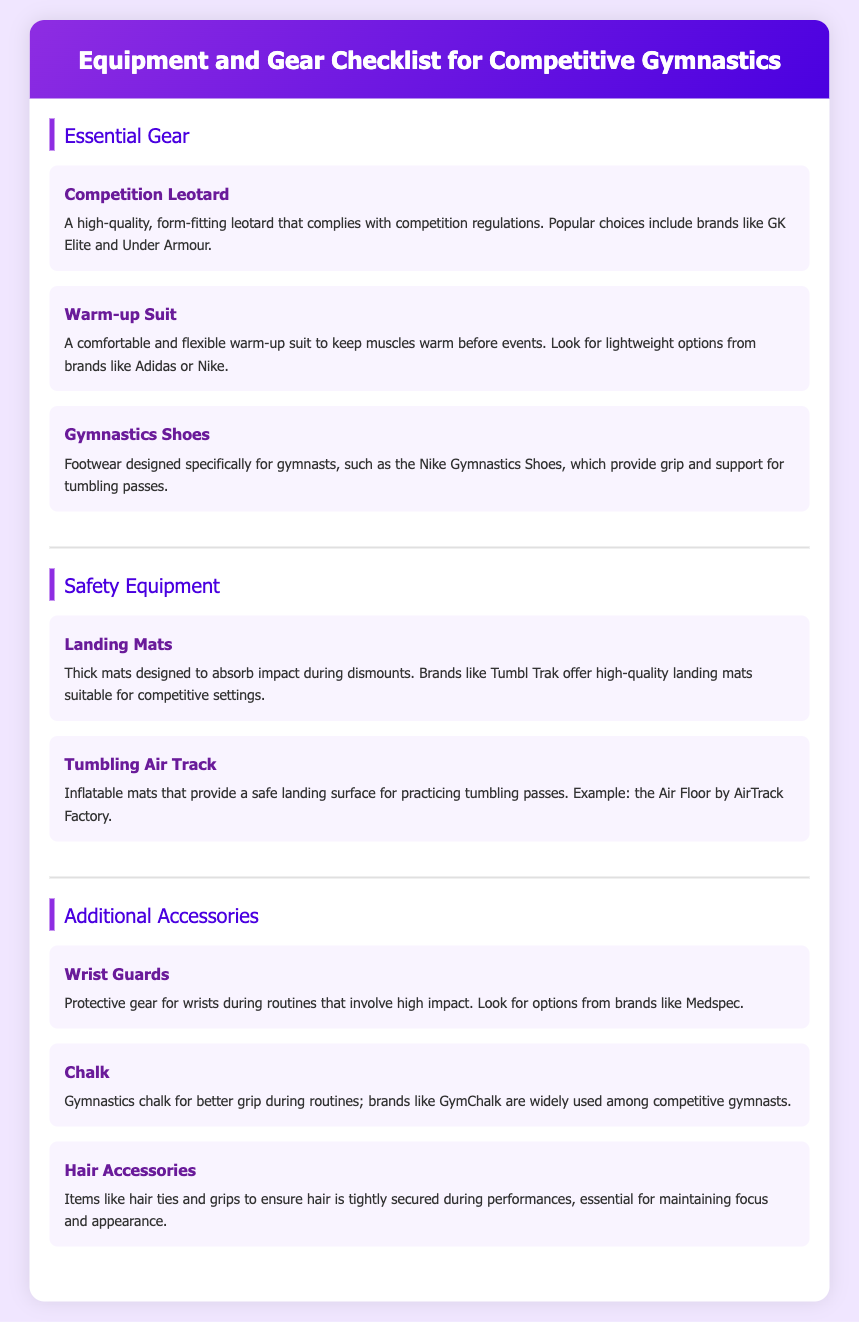What is the title of the document? The title of the document is provided in the header of the page, which states "Equipment and Gear Checklist for Competitive Gymnastics."
Answer: Equipment and Gear Checklist for Competitive Gymnastics Which brand is mentioned for competition leotards? The document specifies that popular choices for competition leotards include brands like GK Elite and Under Armour.
Answer: GK Elite What type of shoes are listed for gymnasts? The document names "Gymnastics Shoes" as the type of footwear designed specifically for gymnasts.
Answer: Gymnastics Shoes What do landing mats provide? According to the document, landing mats are designed to absorb impact during dismounts.
Answer: Absorb impact What is one example of additional accessories mentioned in the document? The listed additional accessories include wrist guards, chalk, and hair accessories; one example is "Wrist Guards."
Answer: Wrist Guards What material is suggested for warm-up suits? The document recommends looking for lightweight options in warm-up suits from brands like Adidas or Nike.
Answer: Lightweight options How many sections are there in the document? The document contains three main sections: Essential Gear, Safety Equipment, and Additional Accessories.
Answer: Three Which inflatable equipment is mentioned for practicing tumbling passes? The document specifies "Tumbling Air Track" as the inflatable equipment used for practicing tumbling.
Answer: Tumbling Air Track What is the purpose of chalk as mentioned in the document? The document states that chalk is used for better grip during routines.
Answer: Better grip 